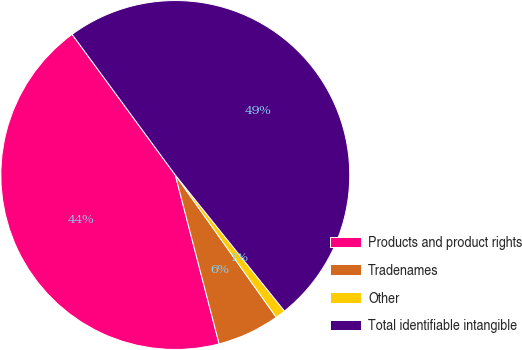Convert chart to OTSL. <chart><loc_0><loc_0><loc_500><loc_500><pie_chart><fcel>Products and product rights<fcel>Tradenames<fcel>Other<fcel>Total identifiable intangible<nl><fcel>43.97%<fcel>5.78%<fcel>0.94%<fcel>49.31%<nl></chart> 